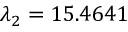Convert formula to latex. <formula><loc_0><loc_0><loc_500><loc_500>\lambda _ { 2 } = 1 5 . 4 6 4 1</formula> 